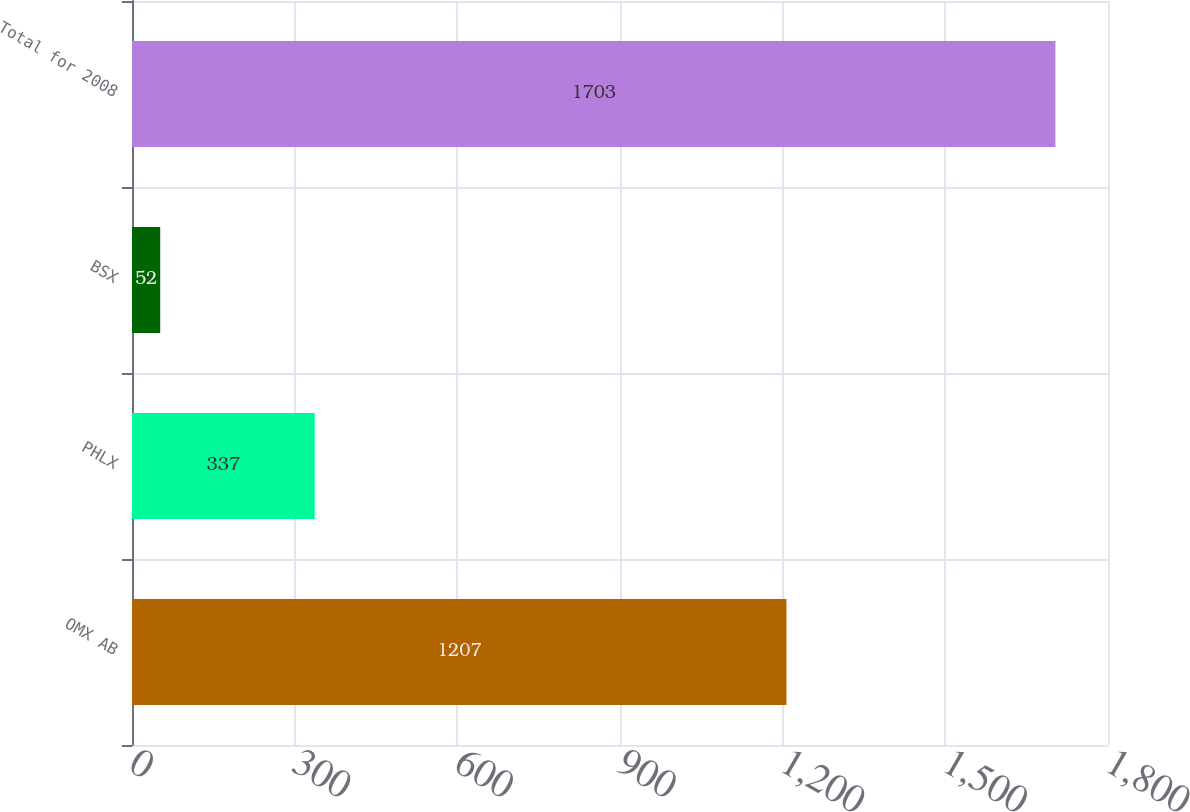Convert chart to OTSL. <chart><loc_0><loc_0><loc_500><loc_500><bar_chart><fcel>OMX AB<fcel>PHLX<fcel>BSX<fcel>Total for 2008<nl><fcel>1207<fcel>337<fcel>52<fcel>1703<nl></chart> 